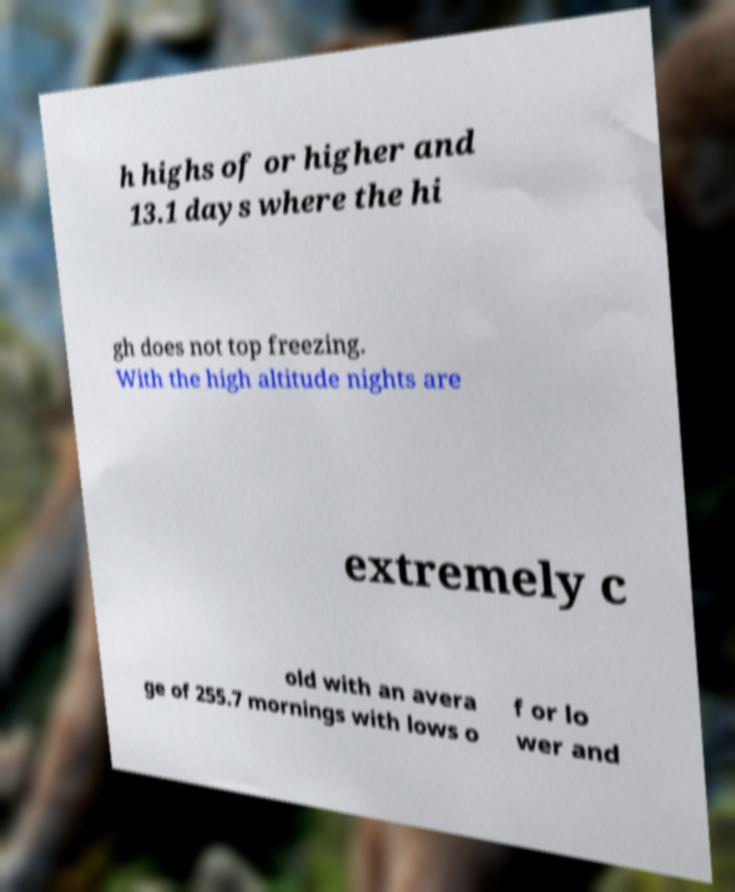What messages or text are displayed in this image? I need them in a readable, typed format. h highs of or higher and 13.1 days where the hi gh does not top freezing. With the high altitude nights are extremely c old with an avera ge of 255.7 mornings with lows o f or lo wer and 